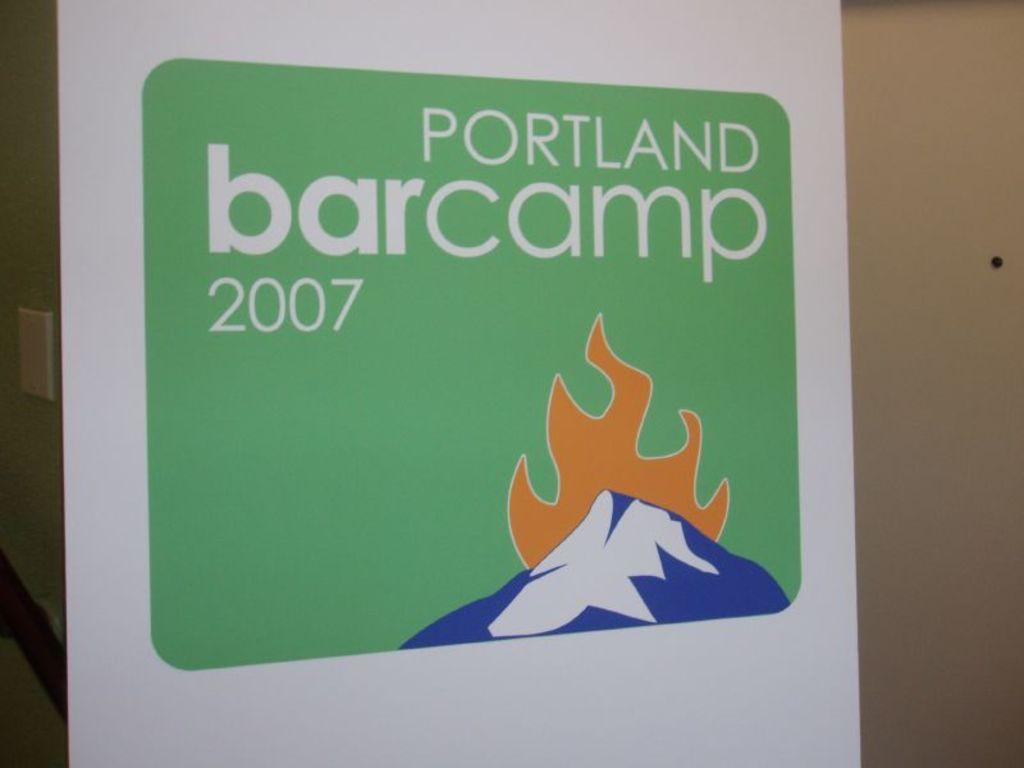<image>
Share a concise interpretation of the image provided. A green sign advertises Portland Bar Camp 2007. 